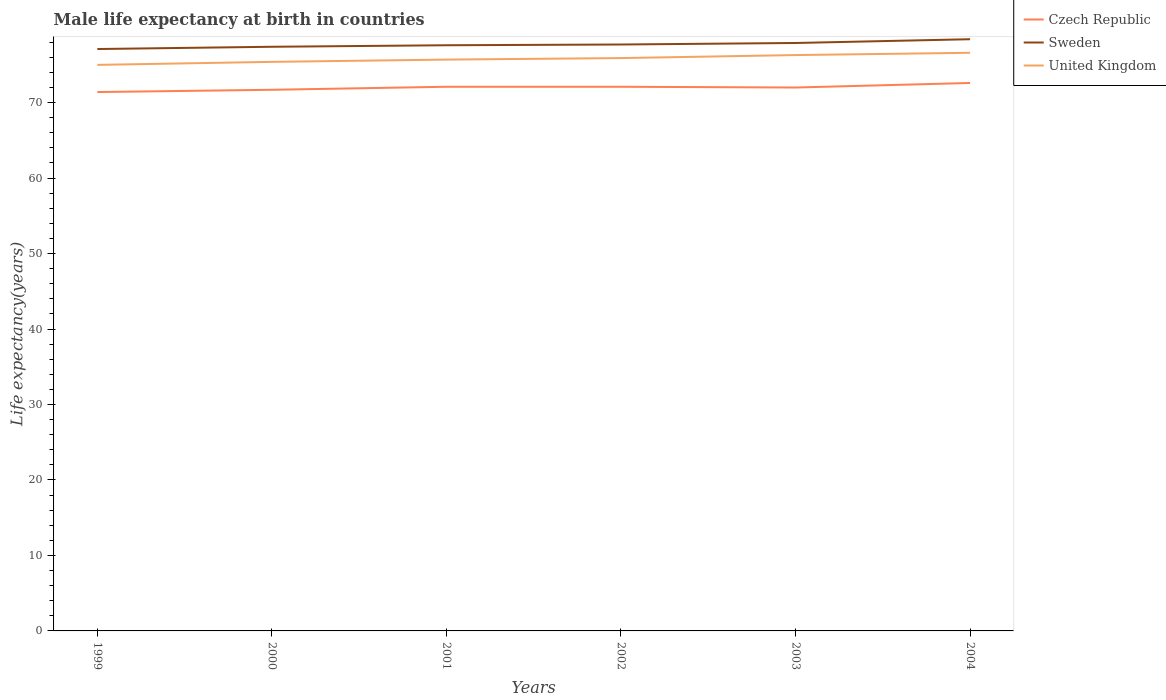Does the line corresponding to Czech Republic intersect with the line corresponding to Sweden?
Your answer should be compact. No. Across all years, what is the maximum male life expectancy at birth in United Kingdom?
Your answer should be very brief. 75. In which year was the male life expectancy at birth in United Kingdom maximum?
Make the answer very short. 1999. What is the total male life expectancy at birth in Czech Republic in the graph?
Keep it short and to the point. -0.5. What is the difference between the highest and the second highest male life expectancy at birth in Sweden?
Make the answer very short. 1.3. What is the difference between the highest and the lowest male life expectancy at birth in Sweden?
Make the answer very short. 3. Is the male life expectancy at birth in United Kingdom strictly greater than the male life expectancy at birth in Sweden over the years?
Your response must be concise. Yes. How many lines are there?
Keep it short and to the point. 3. How many years are there in the graph?
Your answer should be very brief. 6. What is the difference between two consecutive major ticks on the Y-axis?
Offer a terse response. 10. Are the values on the major ticks of Y-axis written in scientific E-notation?
Your response must be concise. No. Does the graph contain any zero values?
Provide a succinct answer. No. Does the graph contain grids?
Your answer should be compact. No. What is the title of the graph?
Offer a very short reply. Male life expectancy at birth in countries. What is the label or title of the Y-axis?
Your answer should be compact. Life expectancy(years). What is the Life expectancy(years) in Czech Republic in 1999?
Provide a succinct answer. 71.4. What is the Life expectancy(years) in Sweden in 1999?
Your answer should be very brief. 77.1. What is the Life expectancy(years) in Czech Republic in 2000?
Provide a short and direct response. 71.7. What is the Life expectancy(years) in Sweden in 2000?
Your response must be concise. 77.4. What is the Life expectancy(years) of United Kingdom in 2000?
Offer a very short reply. 75.4. What is the Life expectancy(years) of Czech Republic in 2001?
Ensure brevity in your answer.  72.1. What is the Life expectancy(years) of Sweden in 2001?
Offer a very short reply. 77.6. What is the Life expectancy(years) of United Kingdom in 2001?
Make the answer very short. 75.7. What is the Life expectancy(years) in Czech Republic in 2002?
Your answer should be compact. 72.1. What is the Life expectancy(years) of Sweden in 2002?
Your response must be concise. 77.7. What is the Life expectancy(years) of United Kingdom in 2002?
Provide a short and direct response. 75.9. What is the Life expectancy(years) of Sweden in 2003?
Offer a terse response. 77.9. What is the Life expectancy(years) of United Kingdom in 2003?
Your answer should be compact. 76.3. What is the Life expectancy(years) in Czech Republic in 2004?
Provide a succinct answer. 72.6. What is the Life expectancy(years) of Sweden in 2004?
Your answer should be very brief. 78.4. What is the Life expectancy(years) in United Kingdom in 2004?
Provide a short and direct response. 76.6. Across all years, what is the maximum Life expectancy(years) of Czech Republic?
Provide a succinct answer. 72.6. Across all years, what is the maximum Life expectancy(years) of Sweden?
Offer a terse response. 78.4. Across all years, what is the maximum Life expectancy(years) in United Kingdom?
Provide a short and direct response. 76.6. Across all years, what is the minimum Life expectancy(years) in Czech Republic?
Ensure brevity in your answer.  71.4. Across all years, what is the minimum Life expectancy(years) in Sweden?
Your response must be concise. 77.1. What is the total Life expectancy(years) in Czech Republic in the graph?
Make the answer very short. 431.9. What is the total Life expectancy(years) of Sweden in the graph?
Offer a very short reply. 466.1. What is the total Life expectancy(years) of United Kingdom in the graph?
Give a very brief answer. 454.9. What is the difference between the Life expectancy(years) in Czech Republic in 1999 and that in 2000?
Offer a terse response. -0.3. What is the difference between the Life expectancy(years) in United Kingdom in 1999 and that in 2000?
Make the answer very short. -0.4. What is the difference between the Life expectancy(years) of Czech Republic in 1999 and that in 2002?
Offer a very short reply. -0.7. What is the difference between the Life expectancy(years) in Sweden in 1999 and that in 2002?
Ensure brevity in your answer.  -0.6. What is the difference between the Life expectancy(years) of Czech Republic in 1999 and that in 2003?
Your answer should be very brief. -0.6. What is the difference between the Life expectancy(years) in Sweden in 1999 and that in 2003?
Keep it short and to the point. -0.8. What is the difference between the Life expectancy(years) of United Kingdom in 1999 and that in 2003?
Your response must be concise. -1.3. What is the difference between the Life expectancy(years) of Sweden in 1999 and that in 2004?
Offer a terse response. -1.3. What is the difference between the Life expectancy(years) of United Kingdom in 1999 and that in 2004?
Make the answer very short. -1.6. What is the difference between the Life expectancy(years) in Sweden in 2000 and that in 2001?
Offer a terse response. -0.2. What is the difference between the Life expectancy(years) of United Kingdom in 2000 and that in 2001?
Your answer should be very brief. -0.3. What is the difference between the Life expectancy(years) of Sweden in 2000 and that in 2002?
Provide a succinct answer. -0.3. What is the difference between the Life expectancy(years) of Czech Republic in 2000 and that in 2004?
Provide a succinct answer. -0.9. What is the difference between the Life expectancy(years) in Czech Republic in 2001 and that in 2003?
Make the answer very short. 0.1. What is the difference between the Life expectancy(years) in United Kingdom in 2001 and that in 2004?
Provide a succinct answer. -0.9. What is the difference between the Life expectancy(years) in Sweden in 2002 and that in 2003?
Your answer should be compact. -0.2. What is the difference between the Life expectancy(years) of United Kingdom in 2002 and that in 2003?
Provide a short and direct response. -0.4. What is the difference between the Life expectancy(years) in Czech Republic in 2002 and that in 2004?
Your response must be concise. -0.5. What is the difference between the Life expectancy(years) of United Kingdom in 2002 and that in 2004?
Provide a short and direct response. -0.7. What is the difference between the Life expectancy(years) of Sweden in 2003 and that in 2004?
Your response must be concise. -0.5. What is the difference between the Life expectancy(years) of United Kingdom in 2003 and that in 2004?
Provide a short and direct response. -0.3. What is the difference between the Life expectancy(years) of Czech Republic in 1999 and the Life expectancy(years) of Sweden in 2000?
Your answer should be compact. -6. What is the difference between the Life expectancy(years) in Czech Republic in 1999 and the Life expectancy(years) in United Kingdom in 2000?
Your answer should be compact. -4. What is the difference between the Life expectancy(years) of Sweden in 1999 and the Life expectancy(years) of United Kingdom in 2000?
Offer a very short reply. 1.7. What is the difference between the Life expectancy(years) in Czech Republic in 1999 and the Life expectancy(years) in United Kingdom in 2001?
Make the answer very short. -4.3. What is the difference between the Life expectancy(years) of Sweden in 1999 and the Life expectancy(years) of United Kingdom in 2001?
Your response must be concise. 1.4. What is the difference between the Life expectancy(years) of Sweden in 1999 and the Life expectancy(years) of United Kingdom in 2002?
Your answer should be very brief. 1.2. What is the difference between the Life expectancy(years) in Czech Republic in 1999 and the Life expectancy(years) in United Kingdom in 2003?
Ensure brevity in your answer.  -4.9. What is the difference between the Life expectancy(years) in Sweden in 1999 and the Life expectancy(years) in United Kingdom in 2003?
Offer a very short reply. 0.8. What is the difference between the Life expectancy(years) of Czech Republic in 1999 and the Life expectancy(years) of United Kingdom in 2004?
Offer a terse response. -5.2. What is the difference between the Life expectancy(years) of Sweden in 2000 and the Life expectancy(years) of United Kingdom in 2001?
Ensure brevity in your answer.  1.7. What is the difference between the Life expectancy(years) of Czech Republic in 2000 and the Life expectancy(years) of United Kingdom in 2002?
Ensure brevity in your answer.  -4.2. What is the difference between the Life expectancy(years) in Czech Republic in 2000 and the Life expectancy(years) in United Kingdom in 2003?
Provide a succinct answer. -4.6. What is the difference between the Life expectancy(years) in Czech Republic in 2000 and the Life expectancy(years) in Sweden in 2004?
Your answer should be compact. -6.7. What is the difference between the Life expectancy(years) in Czech Republic in 2000 and the Life expectancy(years) in United Kingdom in 2004?
Give a very brief answer. -4.9. What is the difference between the Life expectancy(years) of Czech Republic in 2001 and the Life expectancy(years) of United Kingdom in 2003?
Your answer should be compact. -4.2. What is the difference between the Life expectancy(years) in Sweden in 2001 and the Life expectancy(years) in United Kingdom in 2003?
Provide a short and direct response. 1.3. What is the difference between the Life expectancy(years) of Czech Republic in 2001 and the Life expectancy(years) of Sweden in 2004?
Your answer should be compact. -6.3. What is the difference between the Life expectancy(years) in Czech Republic in 2001 and the Life expectancy(years) in United Kingdom in 2004?
Your answer should be very brief. -4.5. What is the difference between the Life expectancy(years) of Sweden in 2001 and the Life expectancy(years) of United Kingdom in 2004?
Your answer should be compact. 1. What is the difference between the Life expectancy(years) of Czech Republic in 2002 and the Life expectancy(years) of Sweden in 2003?
Provide a succinct answer. -5.8. What is the difference between the Life expectancy(years) in Czech Republic in 2002 and the Life expectancy(years) in United Kingdom in 2003?
Your response must be concise. -4.2. What is the difference between the Life expectancy(years) of Czech Republic in 2002 and the Life expectancy(years) of United Kingdom in 2004?
Ensure brevity in your answer.  -4.5. What is the difference between the Life expectancy(years) in Sweden in 2002 and the Life expectancy(years) in United Kingdom in 2004?
Offer a terse response. 1.1. What is the difference between the Life expectancy(years) in Czech Republic in 2003 and the Life expectancy(years) in Sweden in 2004?
Your answer should be very brief. -6.4. What is the average Life expectancy(years) of Czech Republic per year?
Your answer should be very brief. 71.98. What is the average Life expectancy(years) in Sweden per year?
Provide a short and direct response. 77.68. What is the average Life expectancy(years) of United Kingdom per year?
Your answer should be very brief. 75.82. In the year 1999, what is the difference between the Life expectancy(years) in Czech Republic and Life expectancy(years) in United Kingdom?
Your answer should be compact. -3.6. In the year 2000, what is the difference between the Life expectancy(years) in Czech Republic and Life expectancy(years) in Sweden?
Provide a succinct answer. -5.7. In the year 2000, what is the difference between the Life expectancy(years) of Czech Republic and Life expectancy(years) of United Kingdom?
Your response must be concise. -3.7. In the year 2000, what is the difference between the Life expectancy(years) in Sweden and Life expectancy(years) in United Kingdom?
Offer a terse response. 2. In the year 2001, what is the difference between the Life expectancy(years) of Czech Republic and Life expectancy(years) of Sweden?
Ensure brevity in your answer.  -5.5. In the year 2002, what is the difference between the Life expectancy(years) in Czech Republic and Life expectancy(years) in United Kingdom?
Provide a short and direct response. -3.8. In the year 2003, what is the difference between the Life expectancy(years) in Czech Republic and Life expectancy(years) in Sweden?
Keep it short and to the point. -5.9. In the year 2004, what is the difference between the Life expectancy(years) in Czech Republic and Life expectancy(years) in United Kingdom?
Give a very brief answer. -4. In the year 2004, what is the difference between the Life expectancy(years) of Sweden and Life expectancy(years) of United Kingdom?
Give a very brief answer. 1.8. What is the ratio of the Life expectancy(years) in Czech Republic in 1999 to that in 2000?
Offer a terse response. 1. What is the ratio of the Life expectancy(years) in Sweden in 1999 to that in 2000?
Make the answer very short. 1. What is the ratio of the Life expectancy(years) of Czech Republic in 1999 to that in 2001?
Provide a short and direct response. 0.99. What is the ratio of the Life expectancy(years) of United Kingdom in 1999 to that in 2001?
Your answer should be very brief. 0.99. What is the ratio of the Life expectancy(years) in Czech Republic in 1999 to that in 2002?
Make the answer very short. 0.99. What is the ratio of the Life expectancy(years) in Sweden in 1999 to that in 2002?
Your answer should be very brief. 0.99. What is the ratio of the Life expectancy(years) of Czech Republic in 1999 to that in 2004?
Provide a succinct answer. 0.98. What is the ratio of the Life expectancy(years) of Sweden in 1999 to that in 2004?
Your answer should be compact. 0.98. What is the ratio of the Life expectancy(years) of United Kingdom in 1999 to that in 2004?
Keep it short and to the point. 0.98. What is the ratio of the Life expectancy(years) of Czech Republic in 2000 to that in 2001?
Make the answer very short. 0.99. What is the ratio of the Life expectancy(years) in Sweden in 2000 to that in 2001?
Provide a succinct answer. 1. What is the ratio of the Life expectancy(years) of United Kingdom in 2000 to that in 2001?
Give a very brief answer. 1. What is the ratio of the Life expectancy(years) of Czech Republic in 2000 to that in 2002?
Offer a terse response. 0.99. What is the ratio of the Life expectancy(years) in United Kingdom in 2000 to that in 2002?
Offer a terse response. 0.99. What is the ratio of the Life expectancy(years) in Czech Republic in 2000 to that in 2003?
Your answer should be compact. 1. What is the ratio of the Life expectancy(years) in Sweden in 2000 to that in 2003?
Keep it short and to the point. 0.99. What is the ratio of the Life expectancy(years) in United Kingdom in 2000 to that in 2003?
Offer a terse response. 0.99. What is the ratio of the Life expectancy(years) of Czech Republic in 2000 to that in 2004?
Offer a very short reply. 0.99. What is the ratio of the Life expectancy(years) of Sweden in 2000 to that in 2004?
Offer a terse response. 0.99. What is the ratio of the Life expectancy(years) of United Kingdom in 2000 to that in 2004?
Your answer should be very brief. 0.98. What is the ratio of the Life expectancy(years) of Czech Republic in 2001 to that in 2002?
Keep it short and to the point. 1. What is the ratio of the Life expectancy(years) of Sweden in 2001 to that in 2002?
Your response must be concise. 1. What is the ratio of the Life expectancy(years) of United Kingdom in 2001 to that in 2002?
Give a very brief answer. 1. What is the ratio of the Life expectancy(years) in Czech Republic in 2001 to that in 2003?
Your response must be concise. 1. What is the ratio of the Life expectancy(years) of Czech Republic in 2001 to that in 2004?
Provide a succinct answer. 0.99. What is the ratio of the Life expectancy(years) in United Kingdom in 2001 to that in 2004?
Your answer should be compact. 0.99. What is the ratio of the Life expectancy(years) in Czech Republic in 2002 to that in 2004?
Your answer should be compact. 0.99. What is the ratio of the Life expectancy(years) of Sweden in 2002 to that in 2004?
Offer a terse response. 0.99. What is the ratio of the Life expectancy(years) of United Kingdom in 2002 to that in 2004?
Give a very brief answer. 0.99. What is the ratio of the Life expectancy(years) in Sweden in 2003 to that in 2004?
Ensure brevity in your answer.  0.99. What is the ratio of the Life expectancy(years) in United Kingdom in 2003 to that in 2004?
Offer a terse response. 1. What is the difference between the highest and the second highest Life expectancy(years) in Czech Republic?
Keep it short and to the point. 0.5. What is the difference between the highest and the second highest Life expectancy(years) in United Kingdom?
Provide a succinct answer. 0.3. What is the difference between the highest and the lowest Life expectancy(years) in Sweden?
Your response must be concise. 1.3. What is the difference between the highest and the lowest Life expectancy(years) of United Kingdom?
Offer a terse response. 1.6. 